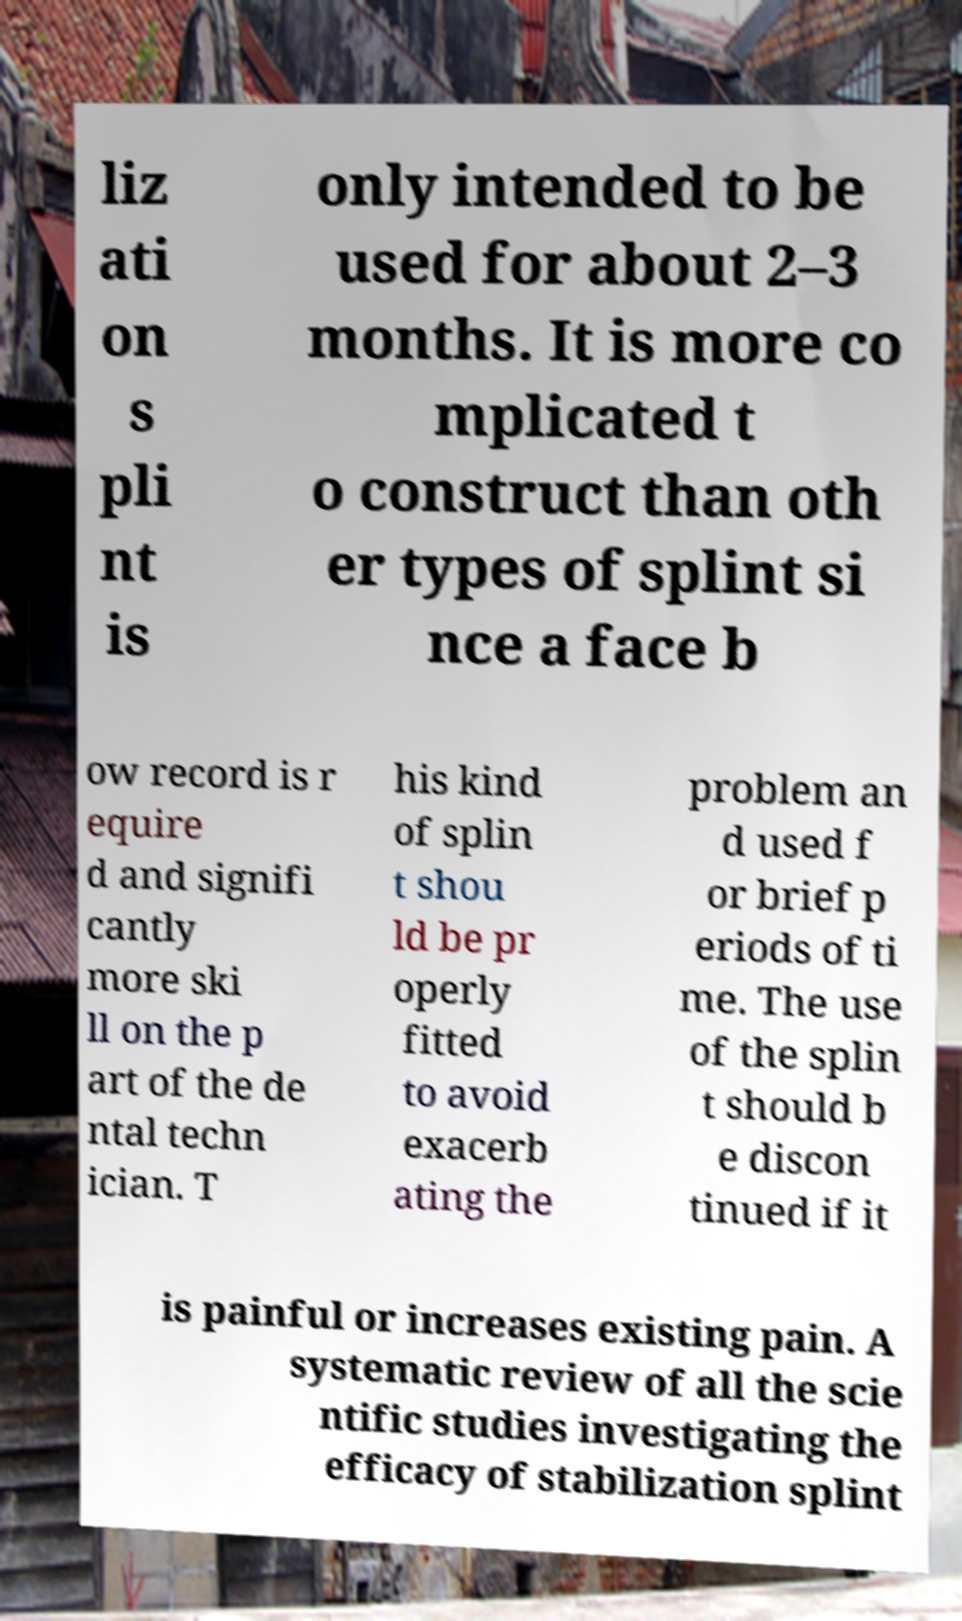What messages or text are displayed in this image? I need them in a readable, typed format. liz ati on s pli nt is only intended to be used for about 2–3 months. It is more co mplicated t o construct than oth er types of splint si nce a face b ow record is r equire d and signifi cantly more ski ll on the p art of the de ntal techn ician. T his kind of splin t shou ld be pr operly fitted to avoid exacerb ating the problem an d used f or brief p eriods of ti me. The use of the splin t should b e discon tinued if it is painful or increases existing pain. A systematic review of all the scie ntific studies investigating the efficacy of stabilization splint 